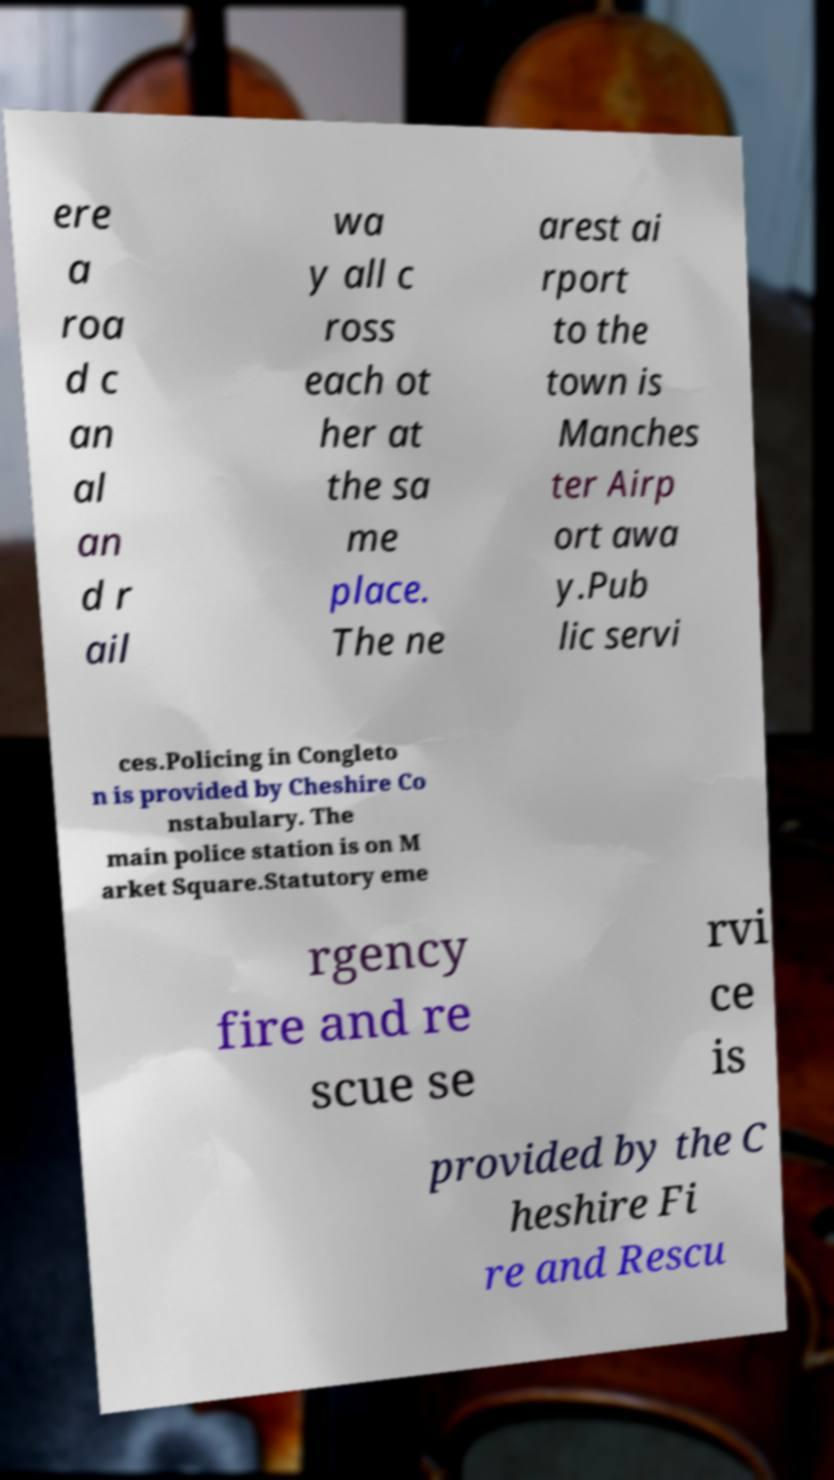For documentation purposes, I need the text within this image transcribed. Could you provide that? ere a roa d c an al an d r ail wa y all c ross each ot her at the sa me place. The ne arest ai rport to the town is Manches ter Airp ort awa y.Pub lic servi ces.Policing in Congleto n is provided by Cheshire Co nstabulary. The main police station is on M arket Square.Statutory eme rgency fire and re scue se rvi ce is provided by the C heshire Fi re and Rescu 